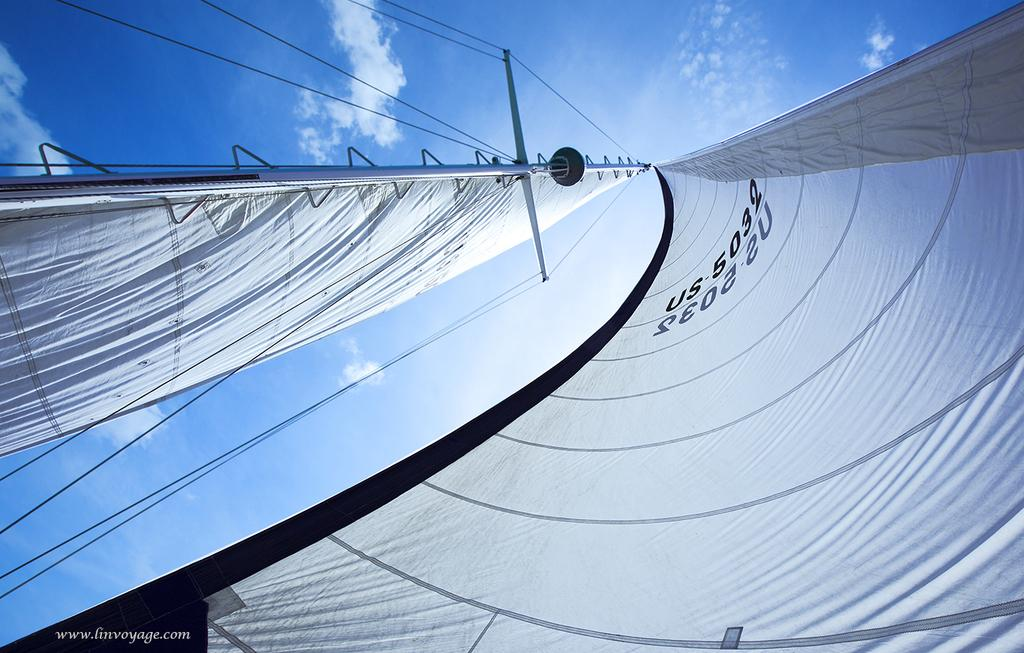What objects are present in the image that are used for hanging clothes? There are poles in the image, and clothes are hanging on them. How are the poles secured in the image? Ropes are tied to the poles. What can be seen on the clothes that are hanging? There is text on the cloth. What is visible in the background of the image? The sky is visible in the image, and it appears to be cloudy. What type of text is present in the image? There is text on the image. What action is the knee performing in the image? There is no knee present in the image, so it is not possible to determine any action it might be performing. 